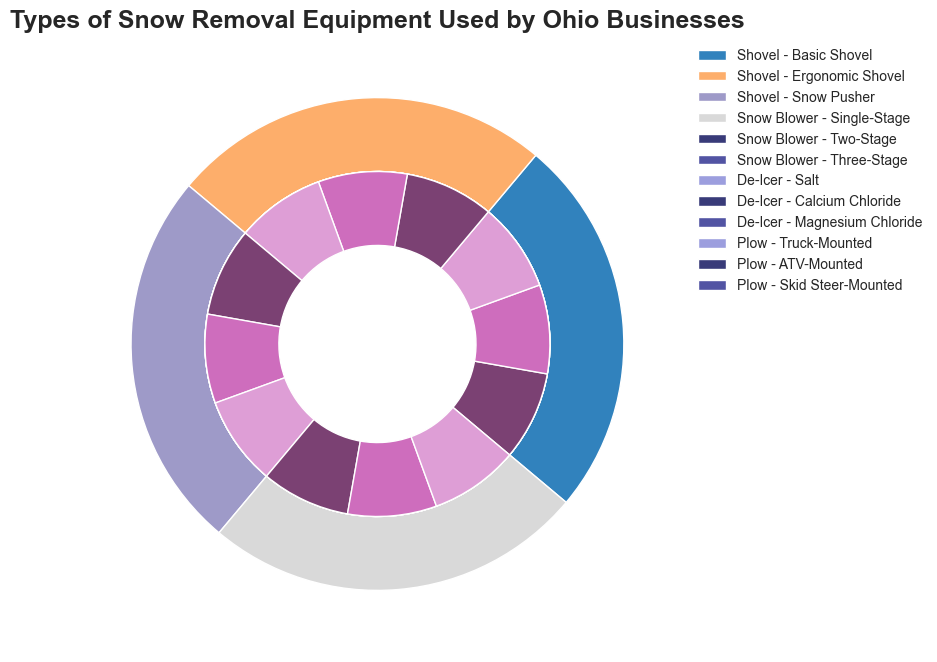What's the most efficient type of snow removal equipment? Refer to the legend and compare the efficiency levels listed for each type and subtype. The subtype "Three-Stage Snow Blower" and "Truck-Mounted Plow" are marked as having "Very High" efficiency, but "Skid Steer-Mounted Plow" is also included as "Very High". The efficiency for "Three-Stage Snow Blower," "Truck-Mounted Plow," and "Skid Steer-Mounted Plow" are the highest.
Answer: Three-Stage Snow Blower, Truck-Mounted Plow, Skid Steer-Mounted Plow Which equipment subtype has the highest cost and lowest availability? Examine the legend to find subtypes with both "Very High" cost and "Low" availability. The subtypes "Three-Stage Snow Blower," "Magnesium Chloride," "Truck-Mounted Plow," and "Skid Steer-Mounted Plow" depict these criteria.
Answer: Three-Stage Snow Blower, Magnesium Chloride, Truck-Mounted Plow, Skid Steer-Mounted Plow What is the total number of subtypes for Snow Blowers? Identify the "Snow Blower" category in the outer pie chart and count the sections in the corresponding inner pie chart. There are three subtypes under "Snow Blower": Single-Stage, Two-Stage, Three-Stage.
Answer: 3 Which subtype of De-Icer equipment has a "Moderate" cost? From the legend, look for De-Icer subtypes and their costs. "Calcium Chloride" is marked with a "Moderate" cost.
Answer: Calcium Chloride What is the most common availability level for snow removal equipment subtypes? Count the instances of each availability level in the legend. The availability levels are noted as "High" for "Basic Shovel," "Ergonomic Shovel," "Salt," and "Calcium Chloride," making "High" the most frequent.
Answer: High Compare the efficiency of "Single-Stage Snow Blower" and "Salt De-Icer." Check the legend and efficiency for "Single-Stage Snow Blower" is "Moderate." The efficiency for "Salt De-Icer" is also "Moderate." They are the same.
Answer: Same Which subtype has the highest combination of high efficiency and low cost? From the legend, cross-examine the efficiency levels and costs. There's no subtype marked with "High" efficiency and "Low" cost. "Salt" has "Moderate" efficiency and "Low" cost but none meets the exact criteria of "High" and "Low."
Answer: None What are the two metrics that "Magnesium Chloride" and "Truck-Mounted Plow" share in common? Refer to the legend for these subtypes. They share "Very High" efficiency and "Low" availability.
Answer: Very High efficiency, Low availability 